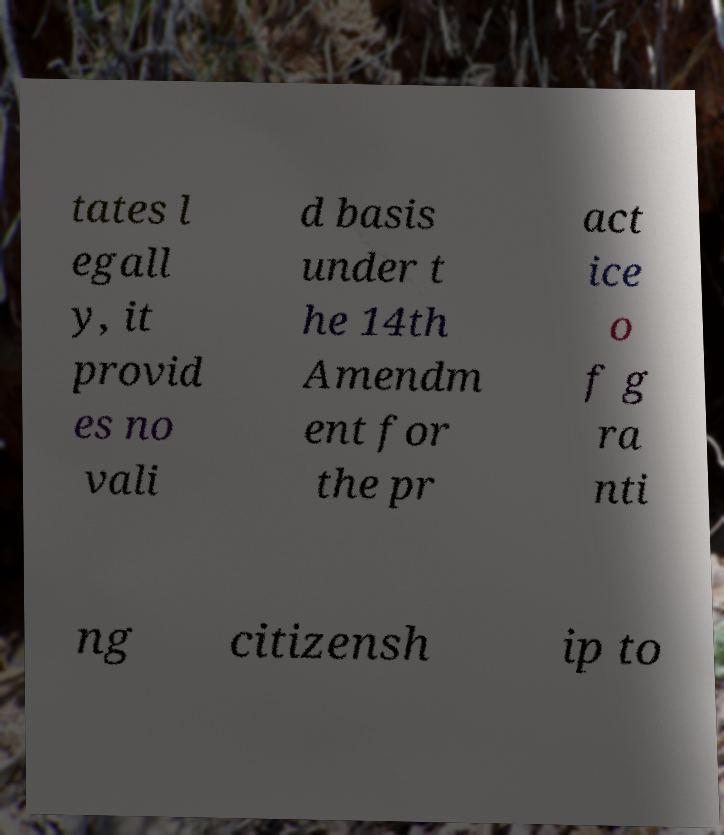I need the written content from this picture converted into text. Can you do that? tates l egall y, it provid es no vali d basis under t he 14th Amendm ent for the pr act ice o f g ra nti ng citizensh ip to 